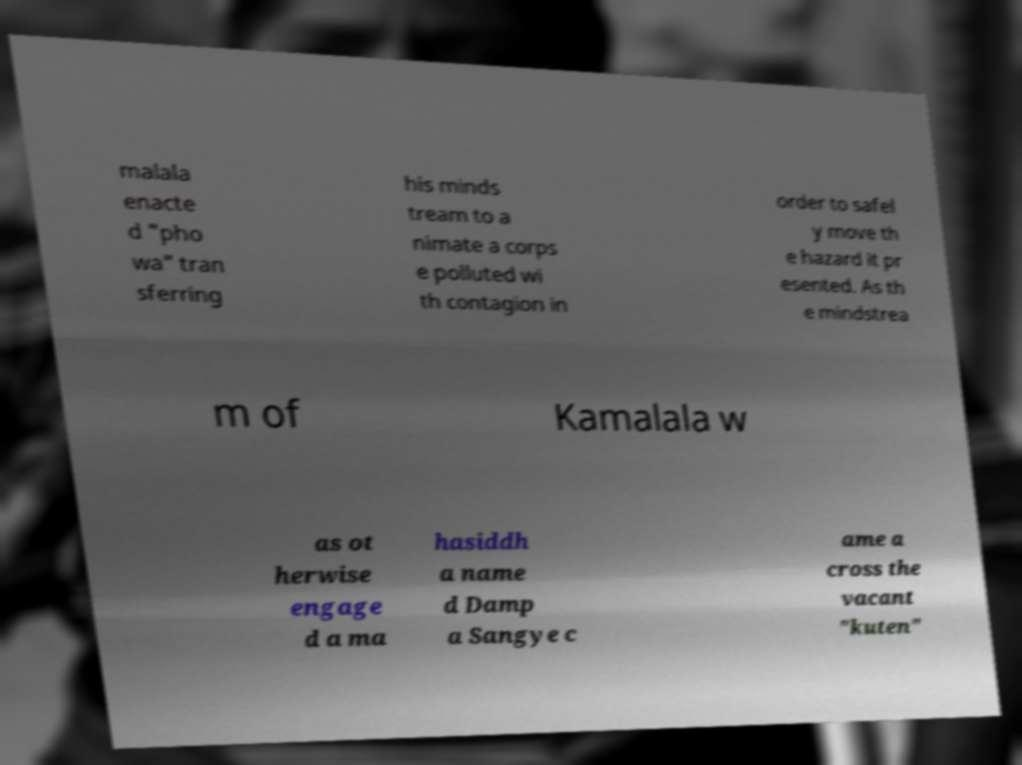There's text embedded in this image that I need extracted. Can you transcribe it verbatim? malala enacte d "pho wa" tran sferring his minds tream to a nimate a corps e polluted wi th contagion in order to safel y move th e hazard it pr esented. As th e mindstrea m of Kamalala w as ot herwise engage d a ma hasiddh a name d Damp a Sangye c ame a cross the vacant "kuten" 